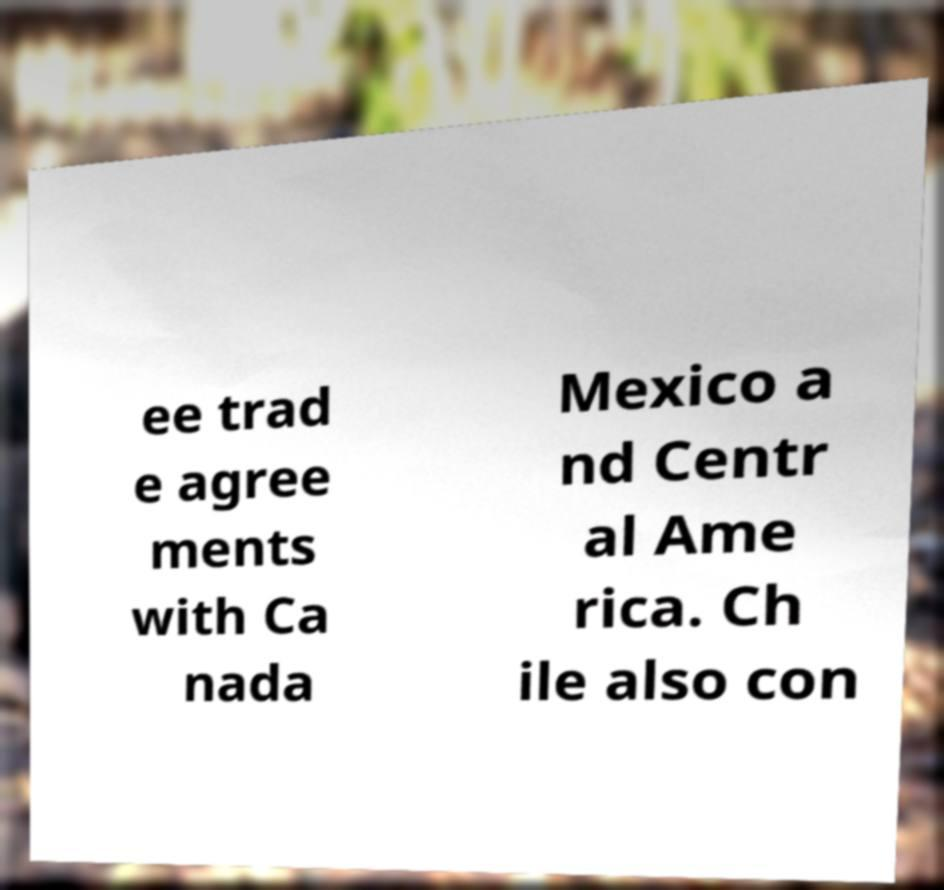For documentation purposes, I need the text within this image transcribed. Could you provide that? ee trad e agree ments with Ca nada Mexico a nd Centr al Ame rica. Ch ile also con 